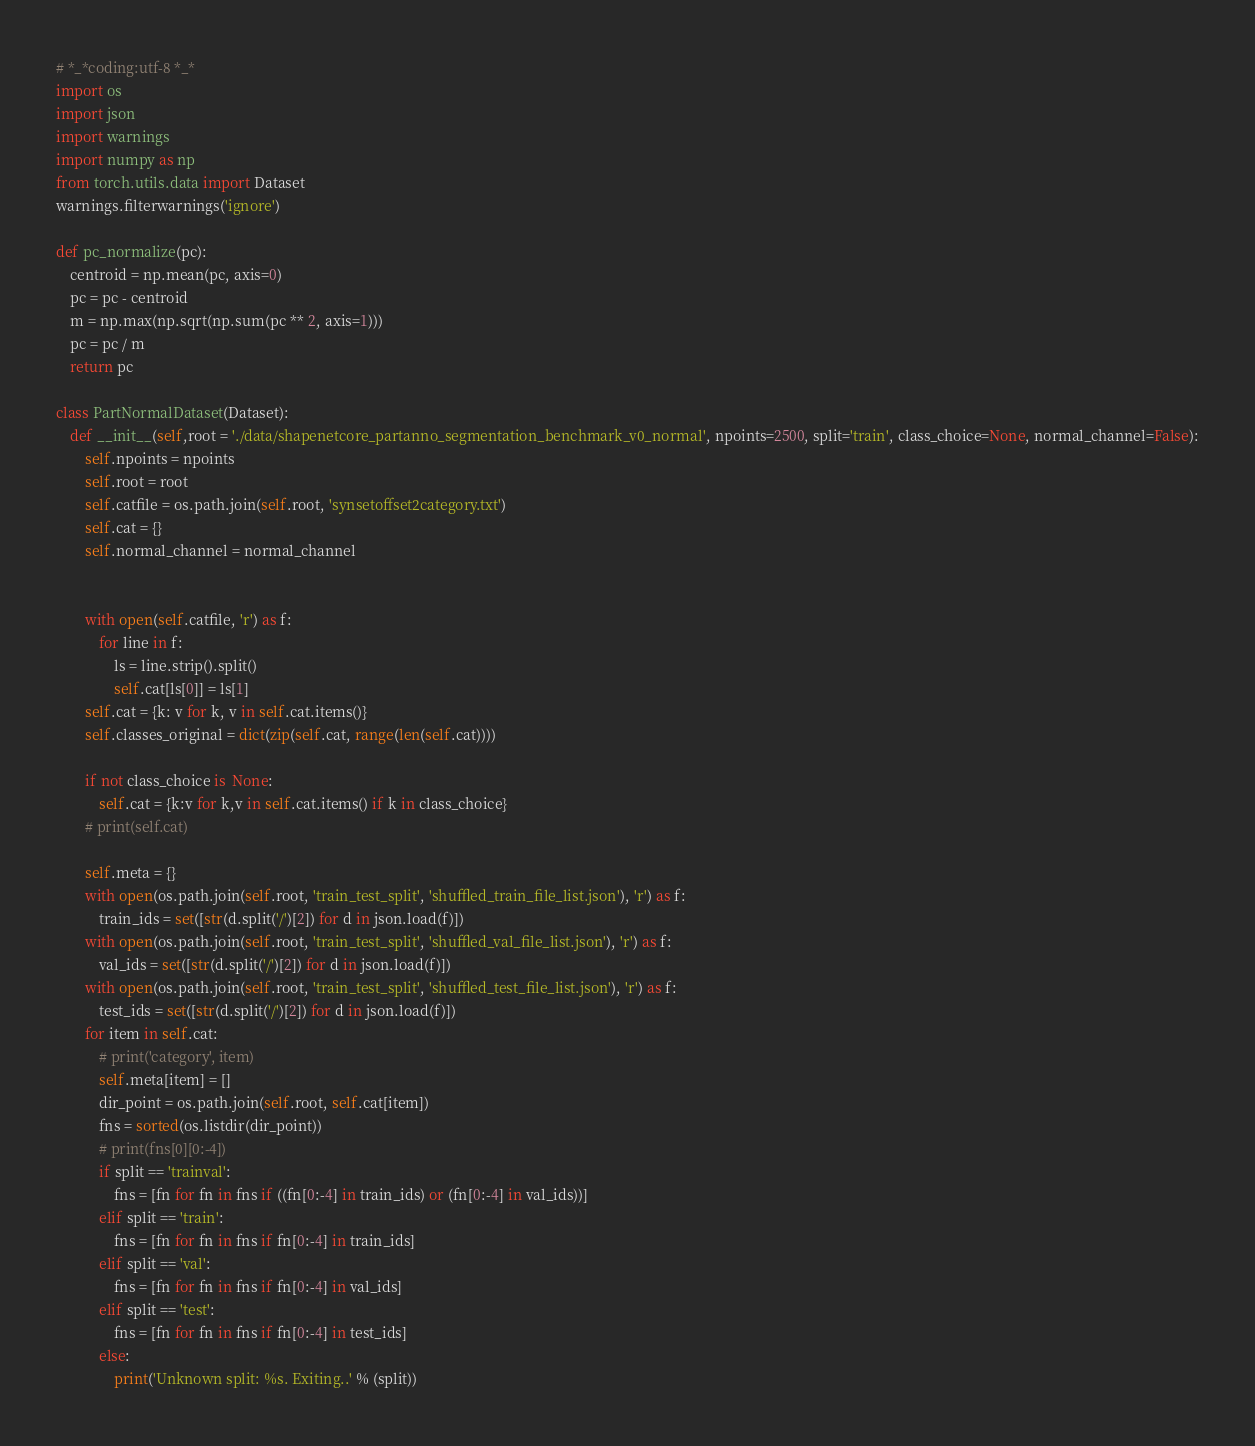<code> <loc_0><loc_0><loc_500><loc_500><_Python_># *_*coding:utf-8 *_*
import os
import json
import warnings
import numpy as np
from torch.utils.data import Dataset
warnings.filterwarnings('ignore')

def pc_normalize(pc):
    centroid = np.mean(pc, axis=0)
    pc = pc - centroid
    m = np.max(np.sqrt(np.sum(pc ** 2, axis=1)))
    pc = pc / m
    return pc

class PartNormalDataset(Dataset):
    def __init__(self,root = './data/shapenetcore_partanno_segmentation_benchmark_v0_normal', npoints=2500, split='train', class_choice=None, normal_channel=False):
        self.npoints = npoints
        self.root = root
        self.catfile = os.path.join(self.root, 'synsetoffset2category.txt')
        self.cat = {}
        self.normal_channel = normal_channel


        with open(self.catfile, 'r') as f:
            for line in f:
                ls = line.strip().split()
                self.cat[ls[0]] = ls[1]
        self.cat = {k: v for k, v in self.cat.items()}
        self.classes_original = dict(zip(self.cat, range(len(self.cat))))

        if not class_choice is  None:
            self.cat = {k:v for k,v in self.cat.items() if k in class_choice}
        # print(self.cat)

        self.meta = {}
        with open(os.path.join(self.root, 'train_test_split', 'shuffled_train_file_list.json'), 'r') as f:
            train_ids = set([str(d.split('/')[2]) for d in json.load(f)])
        with open(os.path.join(self.root, 'train_test_split', 'shuffled_val_file_list.json'), 'r') as f:
            val_ids = set([str(d.split('/')[2]) for d in json.load(f)])
        with open(os.path.join(self.root, 'train_test_split', 'shuffled_test_file_list.json'), 'r') as f:
            test_ids = set([str(d.split('/')[2]) for d in json.load(f)])
        for item in self.cat:
            # print('category', item)
            self.meta[item] = []
            dir_point = os.path.join(self.root, self.cat[item])
            fns = sorted(os.listdir(dir_point))
            # print(fns[0][0:-4])
            if split == 'trainval':
                fns = [fn for fn in fns if ((fn[0:-4] in train_ids) or (fn[0:-4] in val_ids))]
            elif split == 'train':
                fns = [fn for fn in fns if fn[0:-4] in train_ids]
            elif split == 'val':
                fns = [fn for fn in fns if fn[0:-4] in val_ids]
            elif split == 'test':
                fns = [fn for fn in fns if fn[0:-4] in test_ids]
            else:
                print('Unknown split: %s. Exiting..' % (split))</code> 